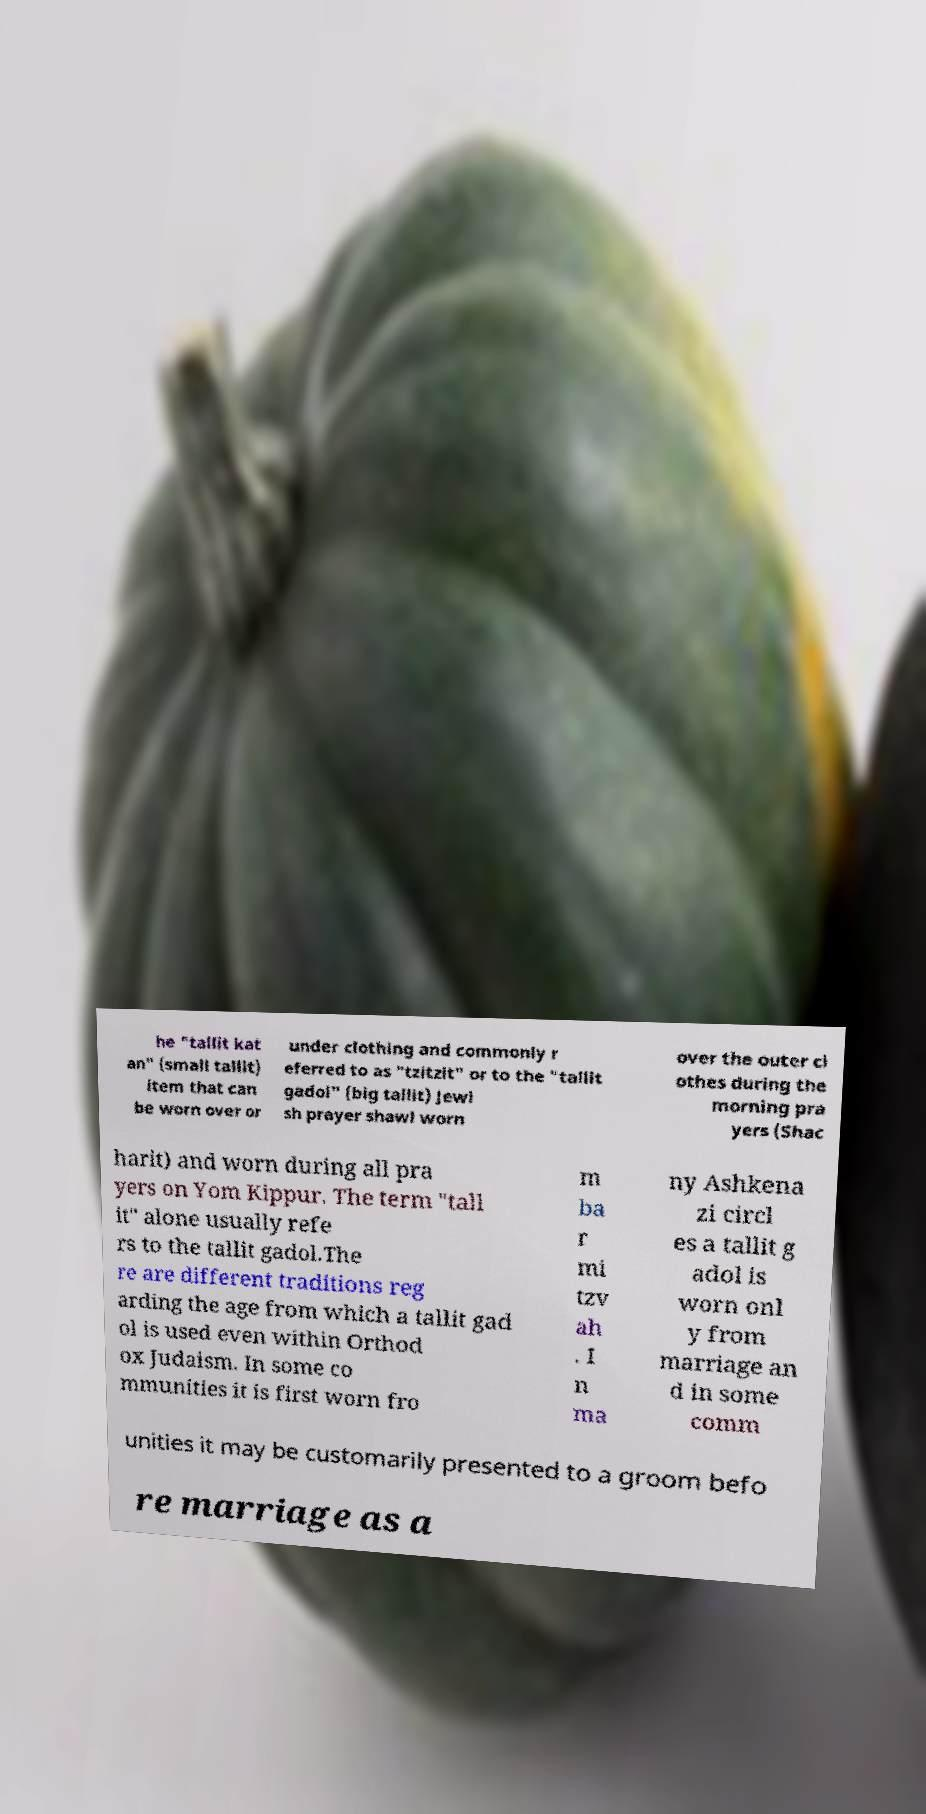What messages or text are displayed in this image? I need them in a readable, typed format. he "tallit kat an" (small tallit) item that can be worn over or under clothing and commonly r eferred to as "tzitzit" or to the "tallit gadol" (big tallit) Jewi sh prayer shawl worn over the outer cl othes during the morning pra yers (Shac harit) and worn during all pra yers on Yom Kippur. The term "tall it" alone usually refe rs to the tallit gadol.The re are different traditions reg arding the age from which a tallit gad ol is used even within Orthod ox Judaism. In some co mmunities it is first worn fro m ba r mi tzv ah . I n ma ny Ashkena zi circl es a tallit g adol is worn onl y from marriage an d in some comm unities it may be customarily presented to a groom befo re marriage as a 